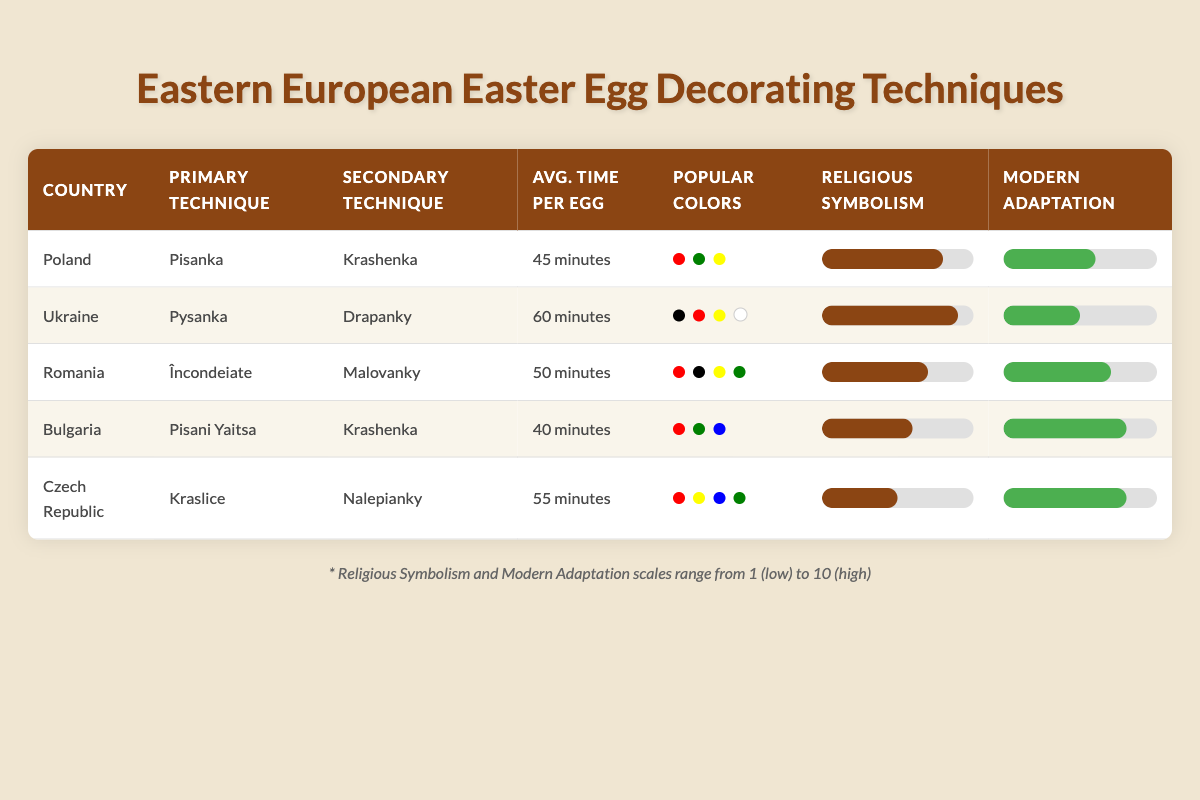What is the primary technique used for egg decorating in Poland? According to the table, Poland's primary technique for egg decorating is "Pisanka."
Answer: Pisanka Which country has the highest average time spent decorating eggs? The average time for each country is listed: Poland (45 min), Ukraine (60 min), Romania (50 min), Bulgaria (40 min), and Czech Republic (55 min). Ukraine has the highest average time at 60 minutes.
Answer: Ukraine True or false: Romania uses "Nalepianky" as its primary egg decorating technique. The table shows that Romania's primary technique is "Încondeiate," not "Nalepianky." Therefore, the statement is false.
Answer: False What is the average religious symbolism score for countries that use "Krashenka" as a technique? Countries using "Krashenka" are Poland and Bulgaria. Their religious symbolism scores are 8 and 6 respectively. To find the average: (8 + 6) / 2 = 7.
Answer: 7 Which country has the most popular colors listed? The table records the popular colors for each country. Ukraine has four colors listed (Black, Red, Yellow, White), while the others have three or fewer. Therefore, Ukraine has the most popular colors.
Answer: Ukraine How does the modern adaptation score for Czech Republic compare to that of Poland? The modern adaptation score for the Czech Republic is 8, and for Poland, it is 6. To compare, 8 is greater than 6, meaning the Czech Republic has a higher score.
Answer: Higher Which egg decorating technique has the lowest average time spent? The average times per egg are as follows: Poland (45 min), Ukraine (60 min), Romania (50 min), Bulgaria (40 min), and Czech Republic (55 min). The lowest is Bulgaria at 40 minutes.
Answer: Bulgaria Is it true that all countries utilize red as a popular color in their egg decorating? The table lists popular colors for each country. Poland, Romania, Bulgaria, and Czech Republic include red; however, Ukraine has no red listed. Therefore, the statement is false.
Answer: False What can you infer about Bulgaria's use of modern adaptation compared to Ukraine's technique? Bulgaria's modern adaptation score is 8, whereas Ukraine's is 5. This indicates that Bulgaria has a more significant modern adaptation in their egg decorating techniques compared to Ukraine.
Answer: Bulgaria has a higher modern adaptation score 